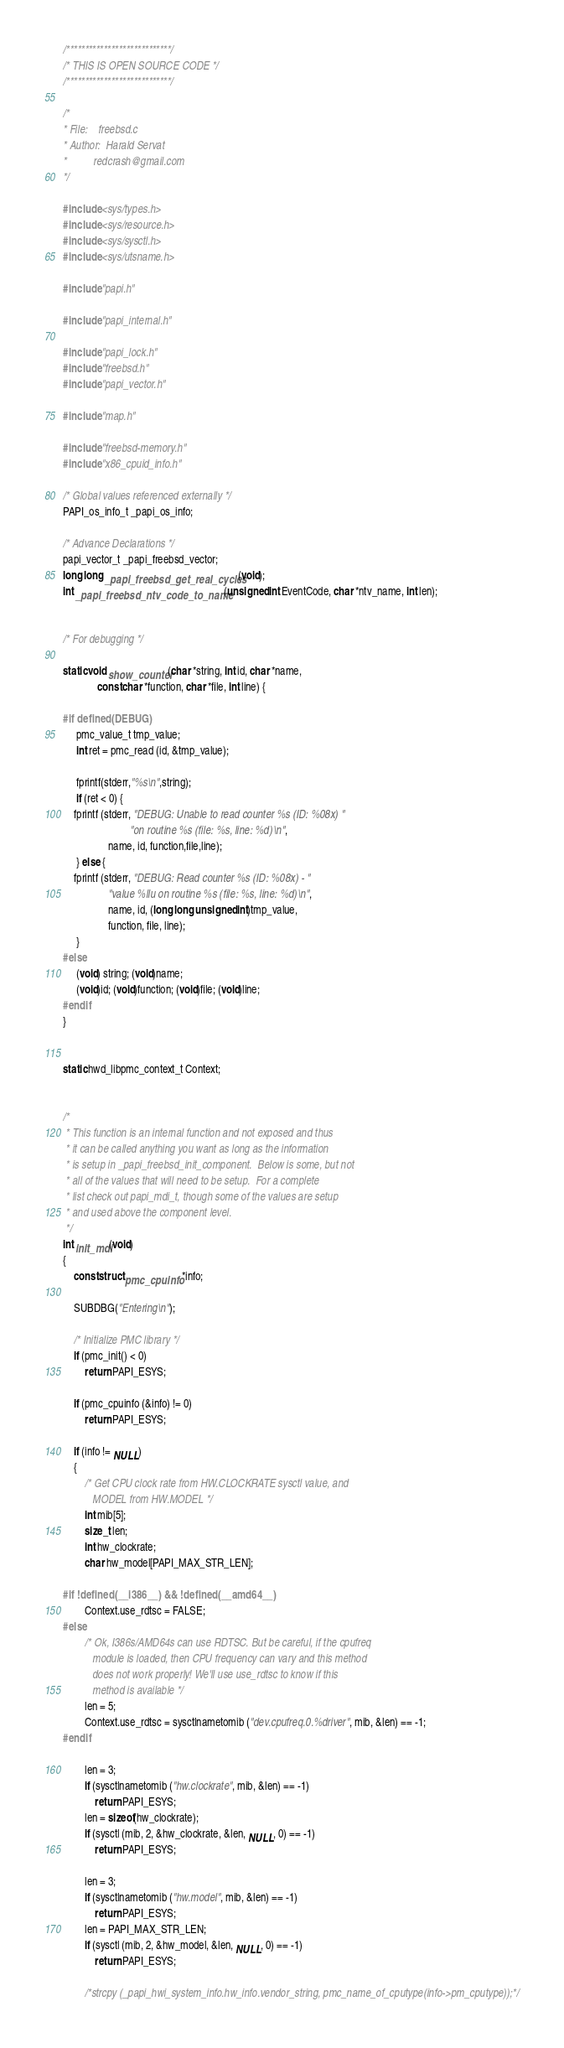<code> <loc_0><loc_0><loc_500><loc_500><_C_>/****************************/
/* THIS IS OPEN SOURCE CODE */
/****************************/

/* 
* File:    freebsd.c
* Author:  Harald Servat
*          redcrash@gmail.com
*/

#include <sys/types.h>
#include <sys/resource.h>
#include <sys/sysctl.h>
#include <sys/utsname.h>

#include "papi.h"

#include "papi_internal.h"

#include "papi_lock.h"
#include "freebsd.h"
#include "papi_vector.h"

#include "map.h"

#include "freebsd-memory.h"
#include "x86_cpuid_info.h"

/* Global values referenced externally */
PAPI_os_info_t _papi_os_info;

/* Advance Declarations */
papi_vector_t _papi_freebsd_vector;
long long _papi_freebsd_get_real_cycles(void);
int _papi_freebsd_ntv_code_to_name(unsigned int EventCode, char *ntv_name, int len);


/* For debugging */

static void show_counter(char *string, int id, char *name,
			 const char *function, char *file, int line) {

#if defined(DEBUG)
     pmc_value_t tmp_value;
     int ret = pmc_read (id, &tmp_value);
     
     fprintf(stderr,"%s\n",string);
     if (ret < 0) {
	fprintf (stderr, "DEBUG: Unable to read counter %s (ID: %08x) "
                         "on routine %s (file: %s, line: %d)\n", 
		         name, id, function,file,line);
     } else {
	fprintf (stderr, "DEBUG: Read counter %s (ID: %08x) - "
		         "value %llu on routine %s (file: %s, line: %d)\n", 
		         name, id, (long long unsigned int)tmp_value, 
		         function, file, line);
     }
#else
     (void) string; (void)name; 
     (void)id; (void)function; (void)file; (void)line;
#endif
}


static hwd_libpmc_context_t Context;


/*
 * This function is an internal function and not exposed and thus
 * it can be called anything you want as long as the information
 * is setup in _papi_freebsd_init_component.  Below is some, but not
 * all of the values that will need to be setup.  For a complete
 * list check out papi_mdi_t, though some of the values are setup
 * and used above the component level.
 */
int init_mdi(void)
{
	const struct pmc_cpuinfo *info;
   
	SUBDBG("Entering\n");

	/* Initialize PMC library */
	if (pmc_init() < 0)
		return PAPI_ESYS;
      
	if (pmc_cpuinfo (&info) != 0)
		return PAPI_ESYS;
   
	if (info != NULL)
	{
		/* Get CPU clock rate from HW.CLOCKRATE sysctl value, and
		   MODEL from HW.MODEL */
		int mib[5];
		size_t len;
		int hw_clockrate;
		char hw_model[PAPI_MAX_STR_LEN];
     
#if !defined(__i386__) && !defined(__amd64__)
		Context.use_rdtsc = FALSE;
#else
		/* Ok, I386s/AMD64s can use RDTSC. But be careful, if the cpufreq
		   module is loaded, then CPU frequency can vary and this method
		   does not work properly! We'll use use_rdtsc to know if this
		   method is available */
		len = 5; 
		Context.use_rdtsc = sysctlnametomib ("dev.cpufreq.0.%driver", mib, &len) == -1;
#endif

		len = 3;
		if (sysctlnametomib ("hw.clockrate", mib, &len) == -1)
			return PAPI_ESYS;
		len = sizeof(hw_clockrate);
		if (sysctl (mib, 2, &hw_clockrate, &len, NULL, 0) == -1)
			return PAPI_ESYS;

		len = 3;
		if (sysctlnametomib ("hw.model", mib, &len) == -1)
			return PAPI_ESYS;
		len = PAPI_MAX_STR_LEN;
		if (sysctl (mib, 2, &hw_model, &len, NULL, 0) == -1)
			return PAPI_ESYS;
		
		/*strcpy (_papi_hwi_system_info.hw_info.vendor_string, pmc_name_of_cputype(info->pm_cputype));*/</code> 